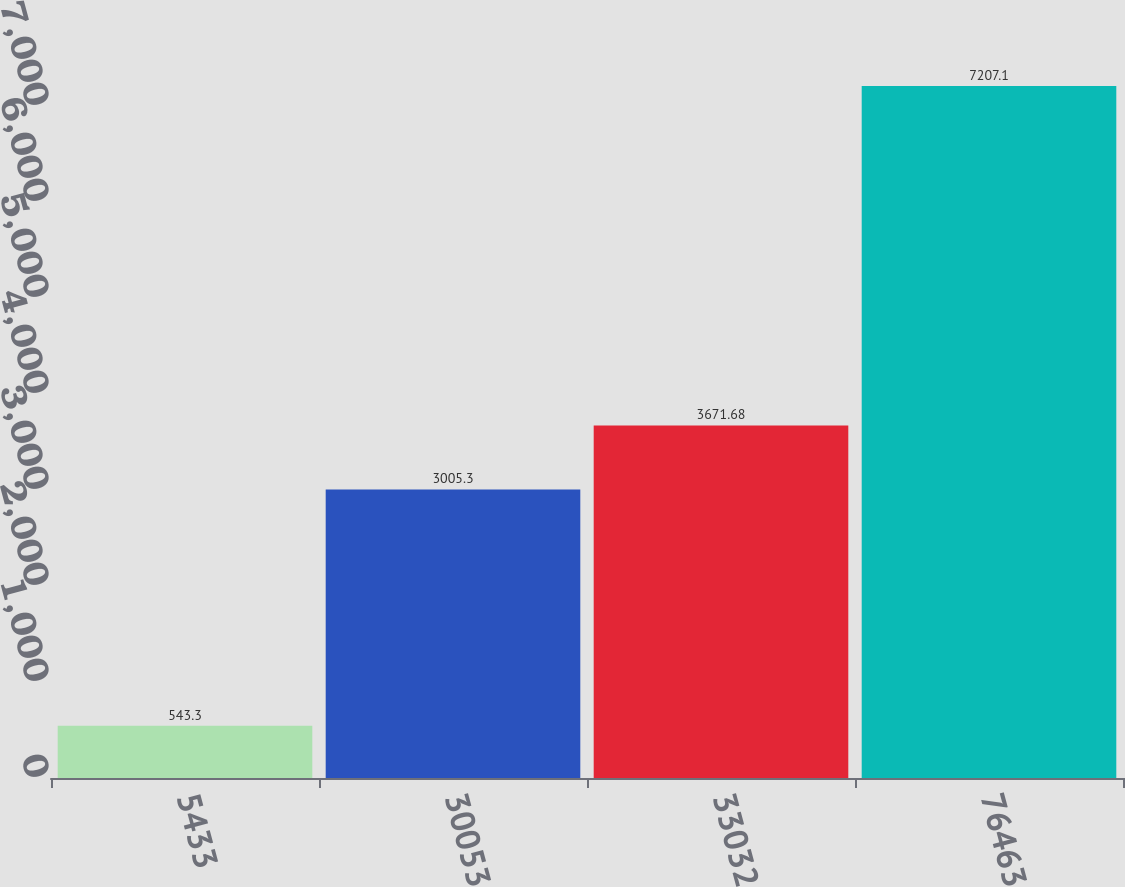Convert chart. <chart><loc_0><loc_0><loc_500><loc_500><bar_chart><fcel>5433<fcel>30053<fcel>33032<fcel>76463<nl><fcel>543.3<fcel>3005.3<fcel>3671.68<fcel>7207.1<nl></chart> 